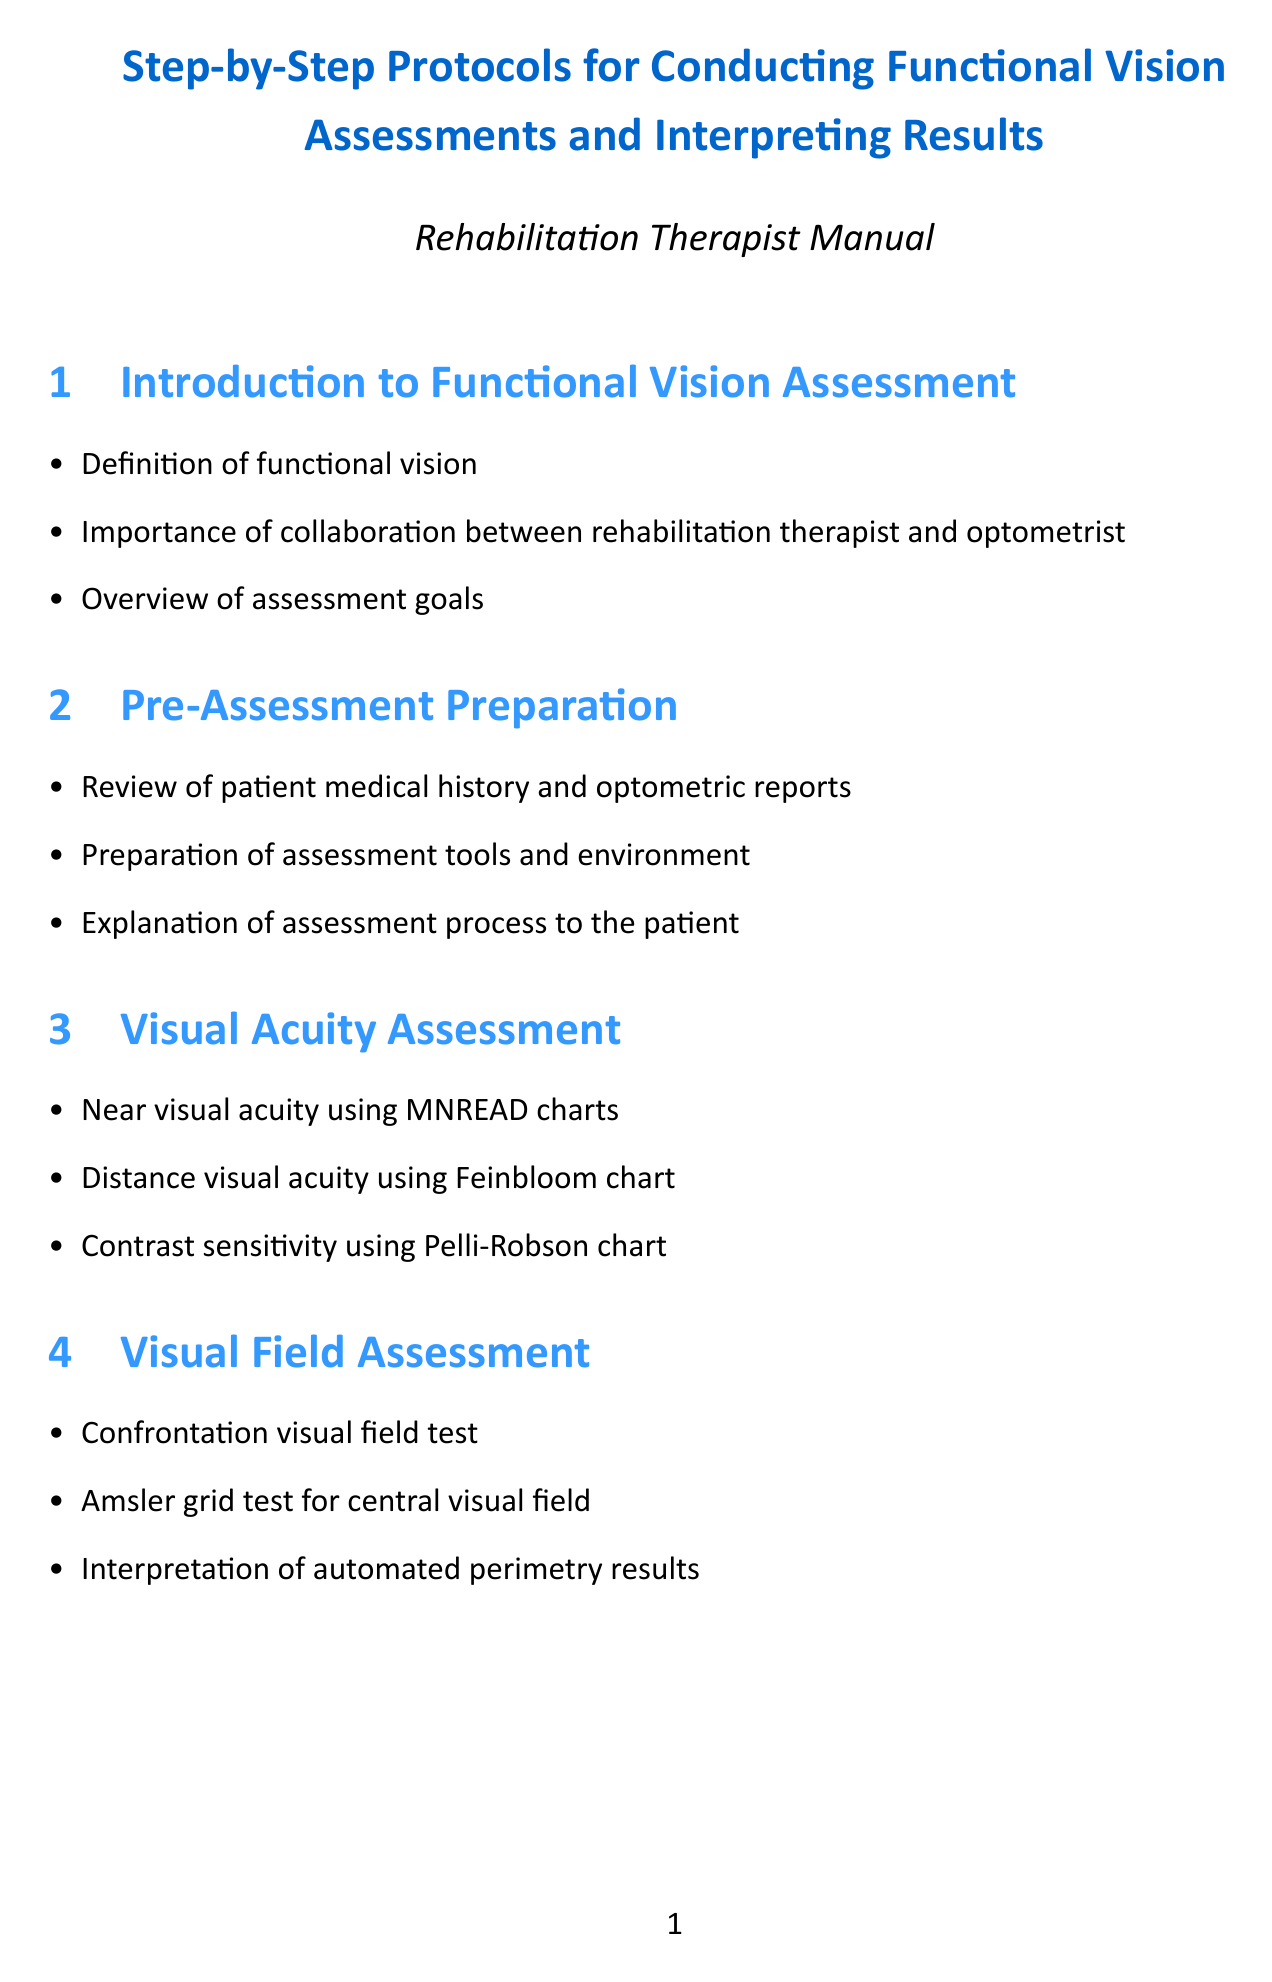What is the first section of the document? The first section is labeled "Introduction to Functional Vision Assessment," which introduces key concepts and goals of the assessment.
Answer: Introduction to Functional Vision Assessment What equipment is used for near visual acuity assessment? The document specifies using MNREAD charts for near visual acuity assessment.
Answer: MNREAD charts What are the components assessed under "Functional Vision Tasks"? "Functional Vision Tasks" includes reading assessment, writing assessment, face recognition, and daily living simulation tasks.
Answer: Reading assessment, Writing assessment, Face recognition, Activities of daily living simulation How many appendices are included in the document? The document includes three appendices, each providing additional resources or tools related to functional vision assessments.
Answer: Three What is evaluated during the "Lighting and Glare Assessment"? The assessment evaluates optimal lighting conditions, glare sensitivity testing, and adaptation to different light levels.
Answer: Optimal lighting conditions, Glare sensitivity testing, Adaptation to different light levels What is required before the assessment process begins? Prior to the assessment, it is crucial to review the patient's medical history and prepare the assessment tools and environment.
Answer: Review of patient medical history and optometric reports, Preparation of assessment tools and environment What does the "Results Interpretation and Reporting" section involve? The results interpretation includes scoring and analysis, comparison with norms, and identifying strengths and limitations of functional vision.
Answer: Scoring and analysis of assessment results, Comparison with age-related norms and previous assessments, Identification of functional vision strengths and limitations Which professionals should collaborate for effective treatment planning? Effective treatment planning involves collaboration between the rehabilitation therapist and the optometrist.
Answer: Rehabilitation therapist and optometrist 